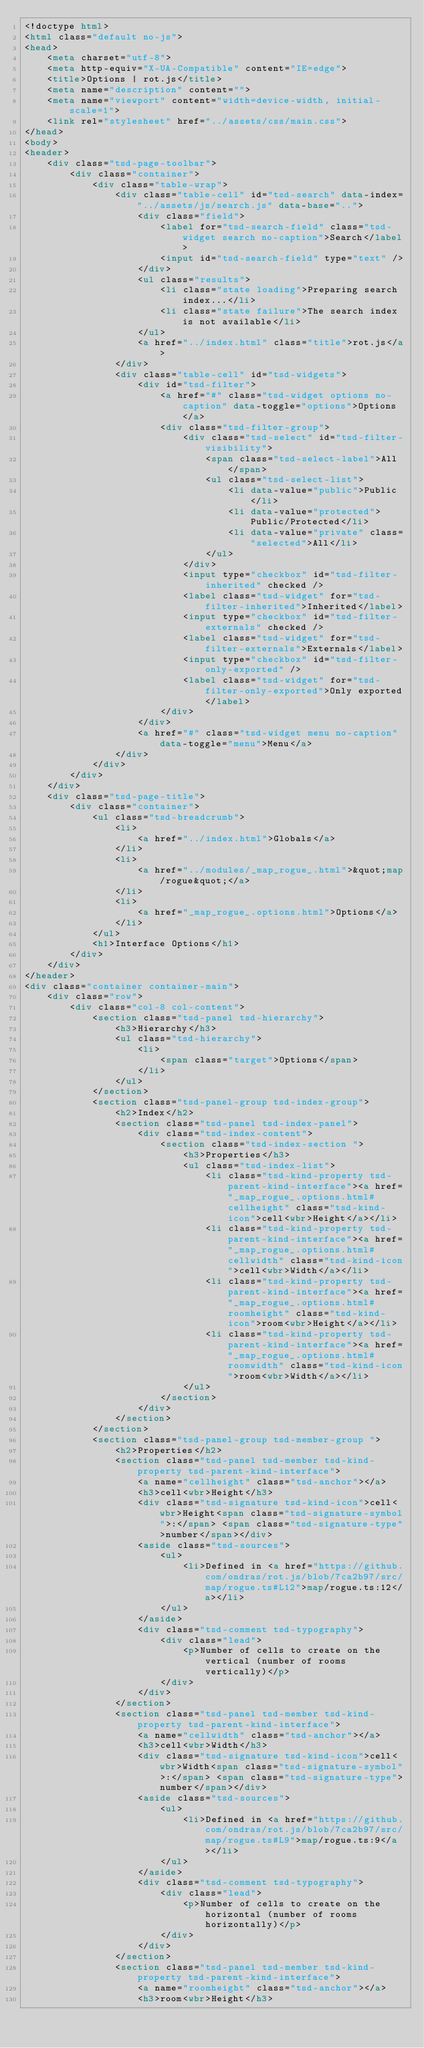Convert code to text. <code><loc_0><loc_0><loc_500><loc_500><_HTML_><!doctype html>
<html class="default no-js">
<head>
	<meta charset="utf-8">
	<meta http-equiv="X-UA-Compatible" content="IE=edge">
	<title>Options | rot.js</title>
	<meta name="description" content="">
	<meta name="viewport" content="width=device-width, initial-scale=1">
	<link rel="stylesheet" href="../assets/css/main.css">
</head>
<body>
<header>
	<div class="tsd-page-toolbar">
		<div class="container">
			<div class="table-wrap">
				<div class="table-cell" id="tsd-search" data-index="../assets/js/search.js" data-base="..">
					<div class="field">
						<label for="tsd-search-field" class="tsd-widget search no-caption">Search</label>
						<input id="tsd-search-field" type="text" />
					</div>
					<ul class="results">
						<li class="state loading">Preparing search index...</li>
						<li class="state failure">The search index is not available</li>
					</ul>
					<a href="../index.html" class="title">rot.js</a>
				</div>
				<div class="table-cell" id="tsd-widgets">
					<div id="tsd-filter">
						<a href="#" class="tsd-widget options no-caption" data-toggle="options">Options</a>
						<div class="tsd-filter-group">
							<div class="tsd-select" id="tsd-filter-visibility">
								<span class="tsd-select-label">All</span>
								<ul class="tsd-select-list">
									<li data-value="public">Public</li>
									<li data-value="protected">Public/Protected</li>
									<li data-value="private" class="selected">All</li>
								</ul>
							</div>
							<input type="checkbox" id="tsd-filter-inherited" checked />
							<label class="tsd-widget" for="tsd-filter-inherited">Inherited</label>
							<input type="checkbox" id="tsd-filter-externals" checked />
							<label class="tsd-widget" for="tsd-filter-externals">Externals</label>
							<input type="checkbox" id="tsd-filter-only-exported" />
							<label class="tsd-widget" for="tsd-filter-only-exported">Only exported</label>
						</div>
					</div>
					<a href="#" class="tsd-widget menu no-caption" data-toggle="menu">Menu</a>
				</div>
			</div>
		</div>
	</div>
	<div class="tsd-page-title">
		<div class="container">
			<ul class="tsd-breadcrumb">
				<li>
					<a href="../index.html">Globals</a>
				</li>
				<li>
					<a href="../modules/_map_rogue_.html">&quot;map/rogue&quot;</a>
				</li>
				<li>
					<a href="_map_rogue_.options.html">Options</a>
				</li>
			</ul>
			<h1>Interface Options</h1>
		</div>
	</div>
</header>
<div class="container container-main">
	<div class="row">
		<div class="col-8 col-content">
			<section class="tsd-panel tsd-hierarchy">
				<h3>Hierarchy</h3>
				<ul class="tsd-hierarchy">
					<li>
						<span class="target">Options</span>
					</li>
				</ul>
			</section>
			<section class="tsd-panel-group tsd-index-group">
				<h2>Index</h2>
				<section class="tsd-panel tsd-index-panel">
					<div class="tsd-index-content">
						<section class="tsd-index-section ">
							<h3>Properties</h3>
							<ul class="tsd-index-list">
								<li class="tsd-kind-property tsd-parent-kind-interface"><a href="_map_rogue_.options.html#cellheight" class="tsd-kind-icon">cell<wbr>Height</a></li>
								<li class="tsd-kind-property tsd-parent-kind-interface"><a href="_map_rogue_.options.html#cellwidth" class="tsd-kind-icon">cell<wbr>Width</a></li>
								<li class="tsd-kind-property tsd-parent-kind-interface"><a href="_map_rogue_.options.html#roomheight" class="tsd-kind-icon">room<wbr>Height</a></li>
								<li class="tsd-kind-property tsd-parent-kind-interface"><a href="_map_rogue_.options.html#roomwidth" class="tsd-kind-icon">room<wbr>Width</a></li>
							</ul>
						</section>
					</div>
				</section>
			</section>
			<section class="tsd-panel-group tsd-member-group ">
				<h2>Properties</h2>
				<section class="tsd-panel tsd-member tsd-kind-property tsd-parent-kind-interface">
					<a name="cellheight" class="tsd-anchor"></a>
					<h3>cell<wbr>Height</h3>
					<div class="tsd-signature tsd-kind-icon">cell<wbr>Height<span class="tsd-signature-symbol">:</span> <span class="tsd-signature-type">number</span></div>
					<aside class="tsd-sources">
						<ul>
							<li>Defined in <a href="https://github.com/ondras/rot.js/blob/7ca2b97/src/map/rogue.ts#L12">map/rogue.ts:12</a></li>
						</ul>
					</aside>
					<div class="tsd-comment tsd-typography">
						<div class="lead">
							<p>Number of cells to create on the vertical (number of rooms vertically)</p>
						</div>
					</div>
				</section>
				<section class="tsd-panel tsd-member tsd-kind-property tsd-parent-kind-interface">
					<a name="cellwidth" class="tsd-anchor"></a>
					<h3>cell<wbr>Width</h3>
					<div class="tsd-signature tsd-kind-icon">cell<wbr>Width<span class="tsd-signature-symbol">:</span> <span class="tsd-signature-type">number</span></div>
					<aside class="tsd-sources">
						<ul>
							<li>Defined in <a href="https://github.com/ondras/rot.js/blob/7ca2b97/src/map/rogue.ts#L9">map/rogue.ts:9</a></li>
						</ul>
					</aside>
					<div class="tsd-comment tsd-typography">
						<div class="lead">
							<p>Number of cells to create on the horizontal (number of rooms horizontally)</p>
						</div>
					</div>
				</section>
				<section class="tsd-panel tsd-member tsd-kind-property tsd-parent-kind-interface">
					<a name="roomheight" class="tsd-anchor"></a>
					<h3>room<wbr>Height</h3></code> 